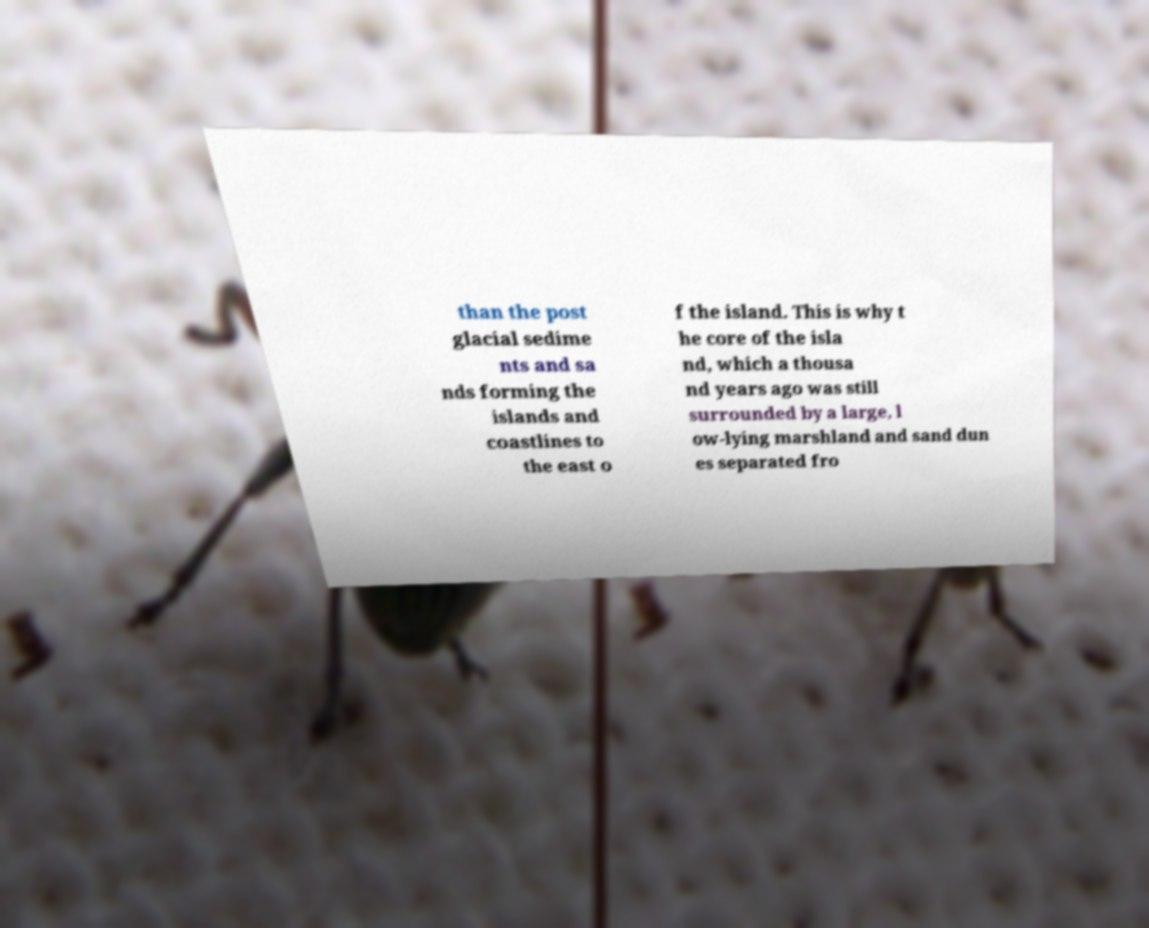Could you extract and type out the text from this image? than the post glacial sedime nts and sa nds forming the islands and coastlines to the east o f the island. This is why t he core of the isla nd, which a thousa nd years ago was still surrounded by a large, l ow-lying marshland and sand dun es separated fro 